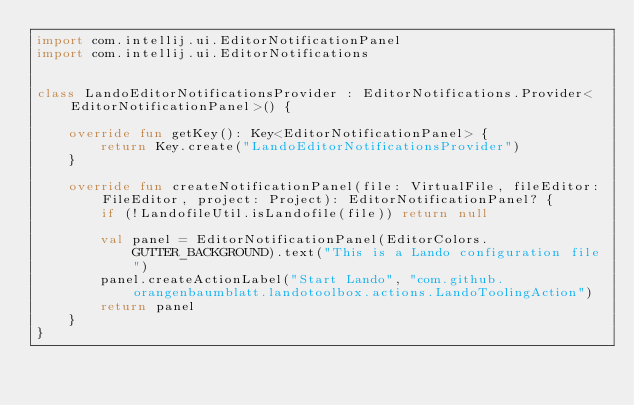Convert code to text. <code><loc_0><loc_0><loc_500><loc_500><_Kotlin_>import com.intellij.ui.EditorNotificationPanel
import com.intellij.ui.EditorNotifications


class LandoEditorNotificationsProvider : EditorNotifications.Provider<EditorNotificationPanel>() {

    override fun getKey(): Key<EditorNotificationPanel> {
        return Key.create("LandoEditorNotificationsProvider")
    }

    override fun createNotificationPanel(file: VirtualFile, fileEditor: FileEditor, project: Project): EditorNotificationPanel? {
        if (!LandofileUtil.isLandofile(file)) return null

        val panel = EditorNotificationPanel(EditorColors.GUTTER_BACKGROUND).text("This is a Lando configuration file")
        panel.createActionLabel("Start Lando", "com.github.orangenbaumblatt.landotoolbox.actions.LandoToolingAction")
        return panel
    }
}
</code> 